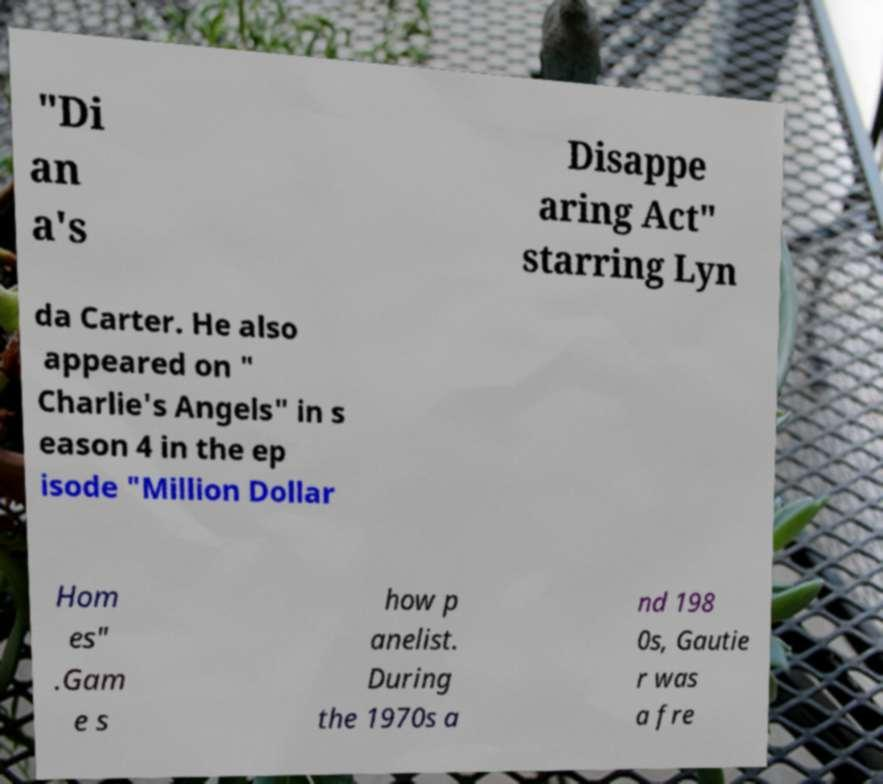Could you assist in decoding the text presented in this image and type it out clearly? "Di an a's Disappe aring Act" starring Lyn da Carter. He also appeared on " Charlie's Angels" in s eason 4 in the ep isode "Million Dollar Hom es" .Gam e s how p anelist. During the 1970s a nd 198 0s, Gautie r was a fre 